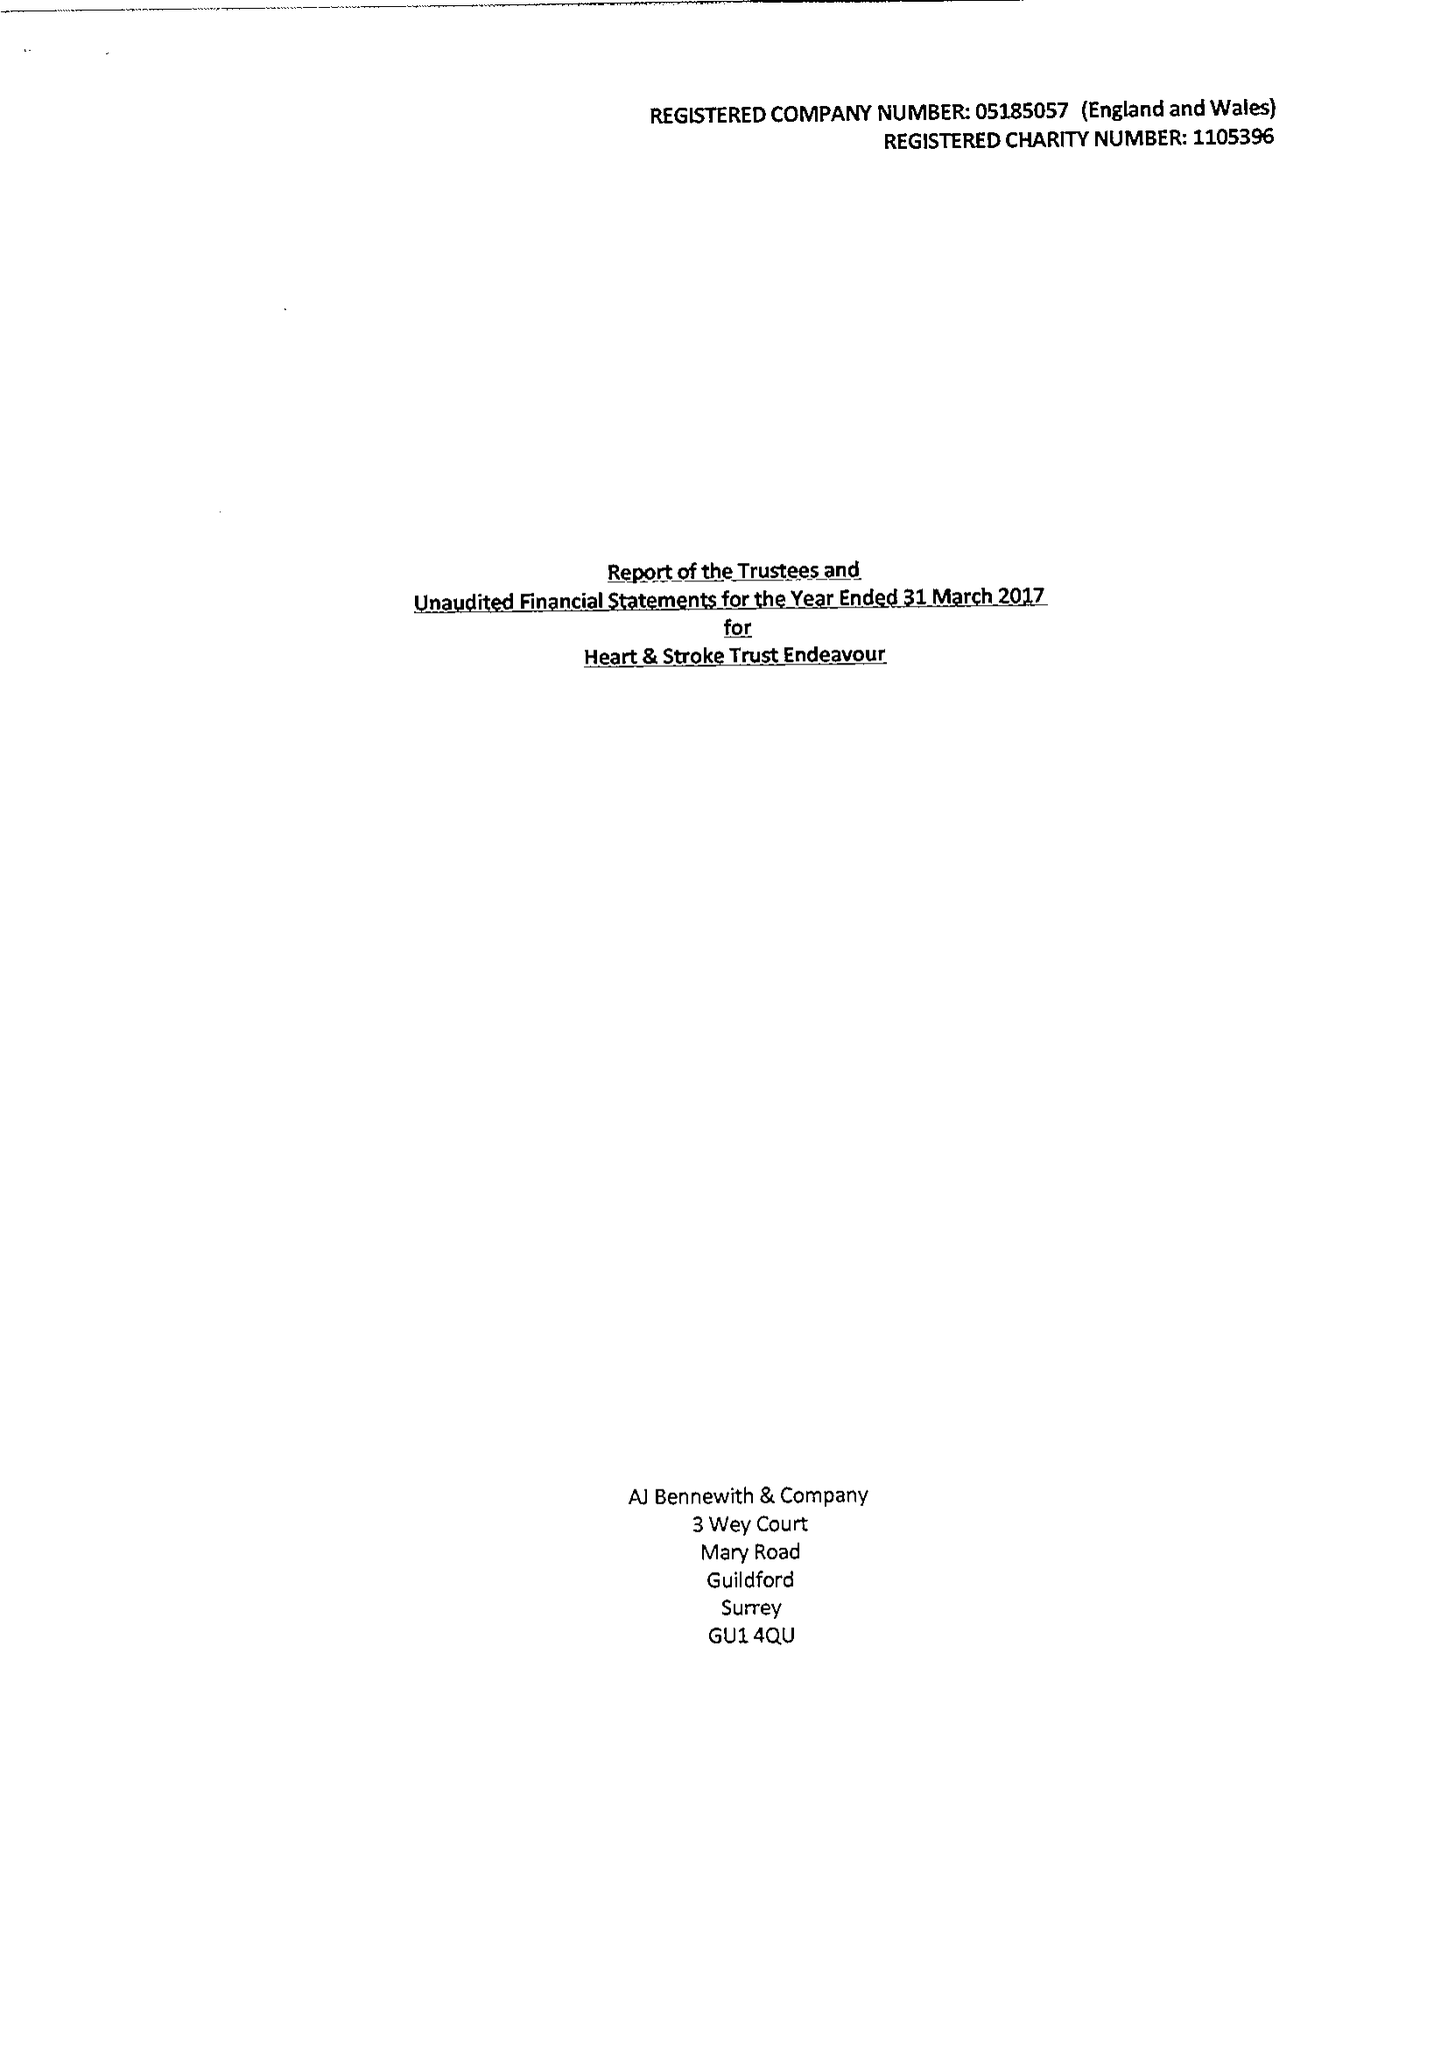What is the value for the report_date?
Answer the question using a single word or phrase. 2017-03-31 